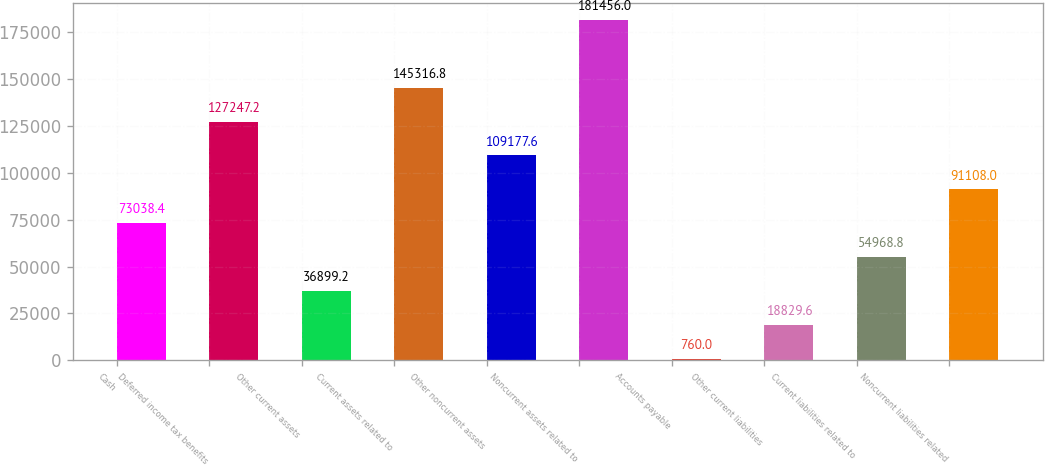Convert chart. <chart><loc_0><loc_0><loc_500><loc_500><bar_chart><fcel>Cash<fcel>Deferred income tax benefits<fcel>Other current assets<fcel>Current assets related to<fcel>Other noncurrent assets<fcel>Noncurrent assets related to<fcel>Accounts payable<fcel>Other current liabilities<fcel>Current liabilities related to<fcel>Noncurrent liabilities related<nl><fcel>73038.4<fcel>127247<fcel>36899.2<fcel>145317<fcel>109178<fcel>181456<fcel>760<fcel>18829.6<fcel>54968.8<fcel>91108<nl></chart> 